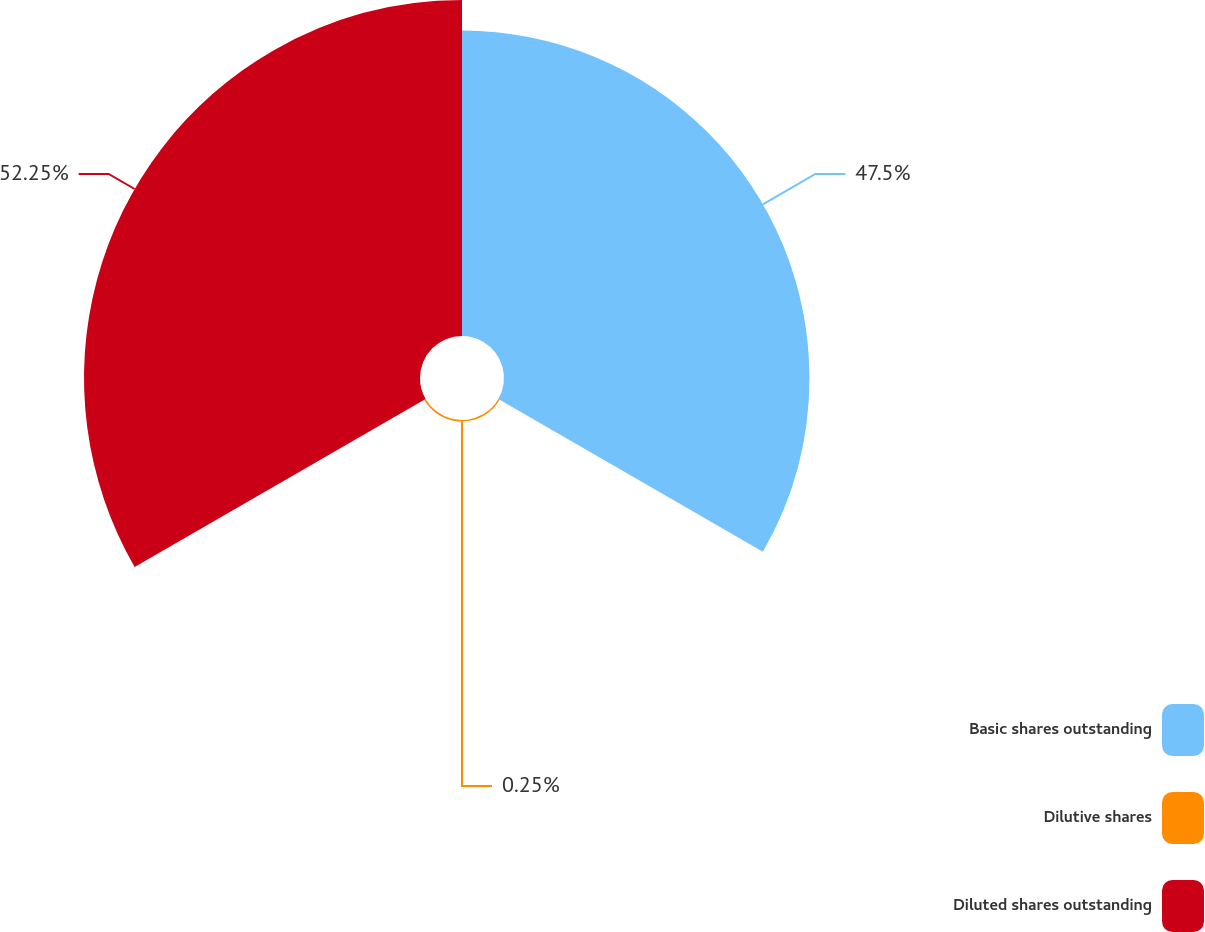Convert chart. <chart><loc_0><loc_0><loc_500><loc_500><pie_chart><fcel>Basic shares outstanding<fcel>Dilutive shares<fcel>Diluted shares outstanding<nl><fcel>47.5%<fcel>0.25%<fcel>52.25%<nl></chart> 